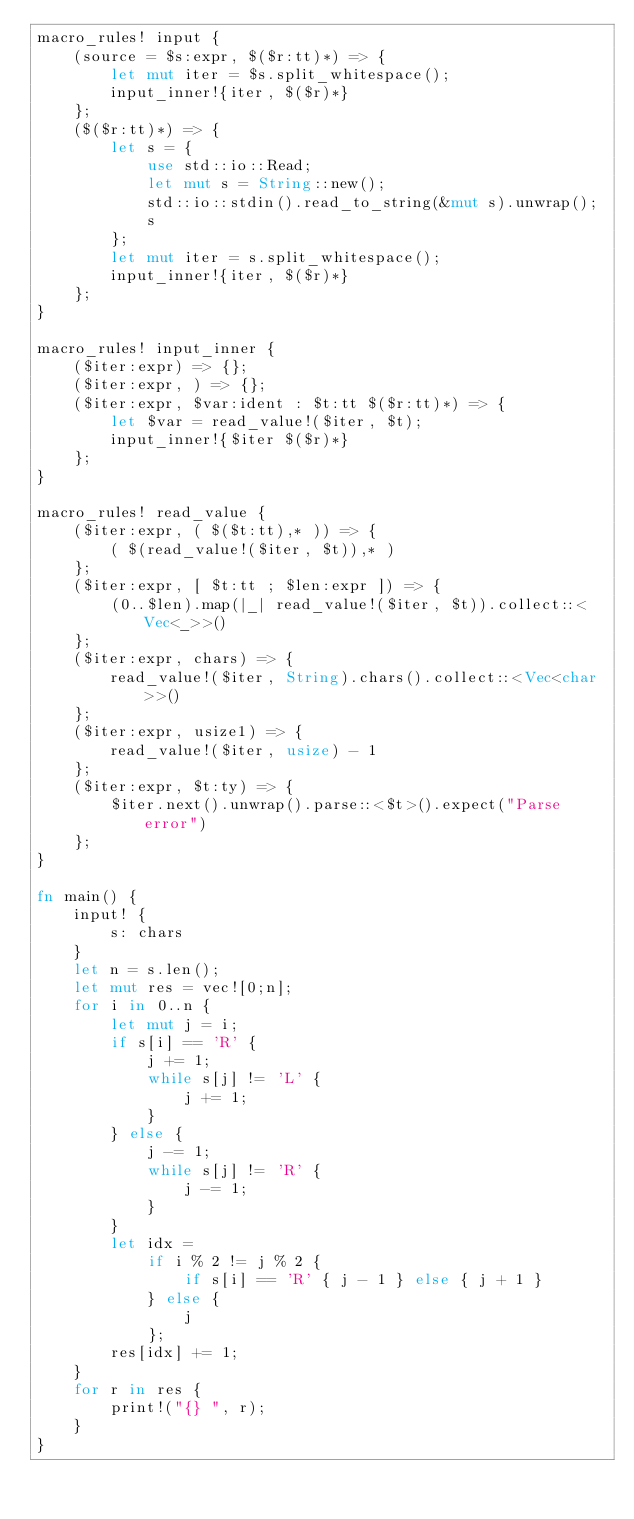<code> <loc_0><loc_0><loc_500><loc_500><_Rust_>macro_rules! input {
    (source = $s:expr, $($r:tt)*) => {
        let mut iter = $s.split_whitespace();
        input_inner!{iter, $($r)*}
    };
    ($($r:tt)*) => {
        let s = {
            use std::io::Read;
            let mut s = String::new();
            std::io::stdin().read_to_string(&mut s).unwrap();
            s
        };
        let mut iter = s.split_whitespace();
        input_inner!{iter, $($r)*}
    };
}

macro_rules! input_inner {
    ($iter:expr) => {};
    ($iter:expr, ) => {};
    ($iter:expr, $var:ident : $t:tt $($r:tt)*) => {
        let $var = read_value!($iter, $t);
        input_inner!{$iter $($r)*}
    };
}

macro_rules! read_value {
    ($iter:expr, ( $($t:tt),* )) => {
        ( $(read_value!($iter, $t)),* )
    };
    ($iter:expr, [ $t:tt ; $len:expr ]) => {
        (0..$len).map(|_| read_value!($iter, $t)).collect::<Vec<_>>()
    };
    ($iter:expr, chars) => {
        read_value!($iter, String).chars().collect::<Vec<char>>()
    };
    ($iter:expr, usize1) => {
        read_value!($iter, usize) - 1
    };
    ($iter:expr, $t:ty) => {
        $iter.next().unwrap().parse::<$t>().expect("Parse error")
    };
}

fn main() {
    input! {
        s: chars
    }
    let n = s.len();
    let mut res = vec![0;n];
    for i in 0..n {
        let mut j = i;
        if s[i] == 'R' {
            j += 1;
            while s[j] != 'L' {
                j += 1;
            }
        } else {
            j -= 1;
            while s[j] != 'R' {
                j -= 1;
            }
        }
        let idx =
            if i % 2 != j % 2 {
                if s[i] == 'R' { j - 1 } else { j + 1 }
            } else {
                j
            };
        res[idx] += 1;
    }
    for r in res {
        print!("{} ", r);
    }
}
</code> 